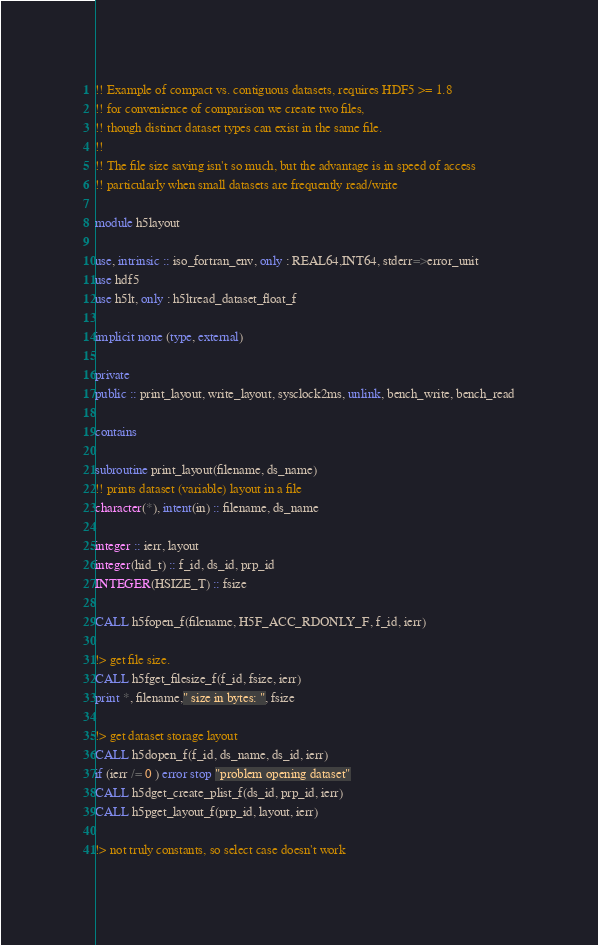Convert code to text. <code><loc_0><loc_0><loc_500><loc_500><_FORTRAN_>!! Example of compact vs. contiguous datasets, requires HDF5 >= 1.8
!! for convenience of comparison we create two files,
!! though distinct dataset types can exist in the same file.
!!
!! The file size saving isn't so much, but the advantage is in speed of access
!! particularly when small datasets are frequently read/write

module h5layout

use, intrinsic :: iso_fortran_env, only : REAL64,INT64, stderr=>error_unit
use hdf5
use h5lt, only : h5ltread_dataset_float_f

implicit none (type, external)

private
public :: print_layout, write_layout, sysclock2ms, unlink, bench_write, bench_read

contains

subroutine print_layout(filename, ds_name)
!! prints dataset (variable) layout in a file
character(*), intent(in) :: filename, ds_name

integer :: ierr, layout
integer(hid_t) :: f_id, ds_id, prp_id
INTEGER(HSIZE_T) :: fsize

CALL h5fopen_f(filename, H5F_ACC_RDONLY_F, f_id, ierr)

!> get file size.
CALL h5fget_filesize_f(f_id, fsize, ierr)
print *, filename," size in bytes: ", fsize

!> get dataset storage layout
CALL h5dopen_f(f_id, ds_name, ds_id, ierr)
if (ierr /= 0 ) error stop "problem opening dataset"
CALL h5dget_create_plist_f(ds_id, prp_id, ierr)
CALL h5pget_layout_f(prp_id, layout, ierr)

!> not truly constants, so select case doesn't work</code> 